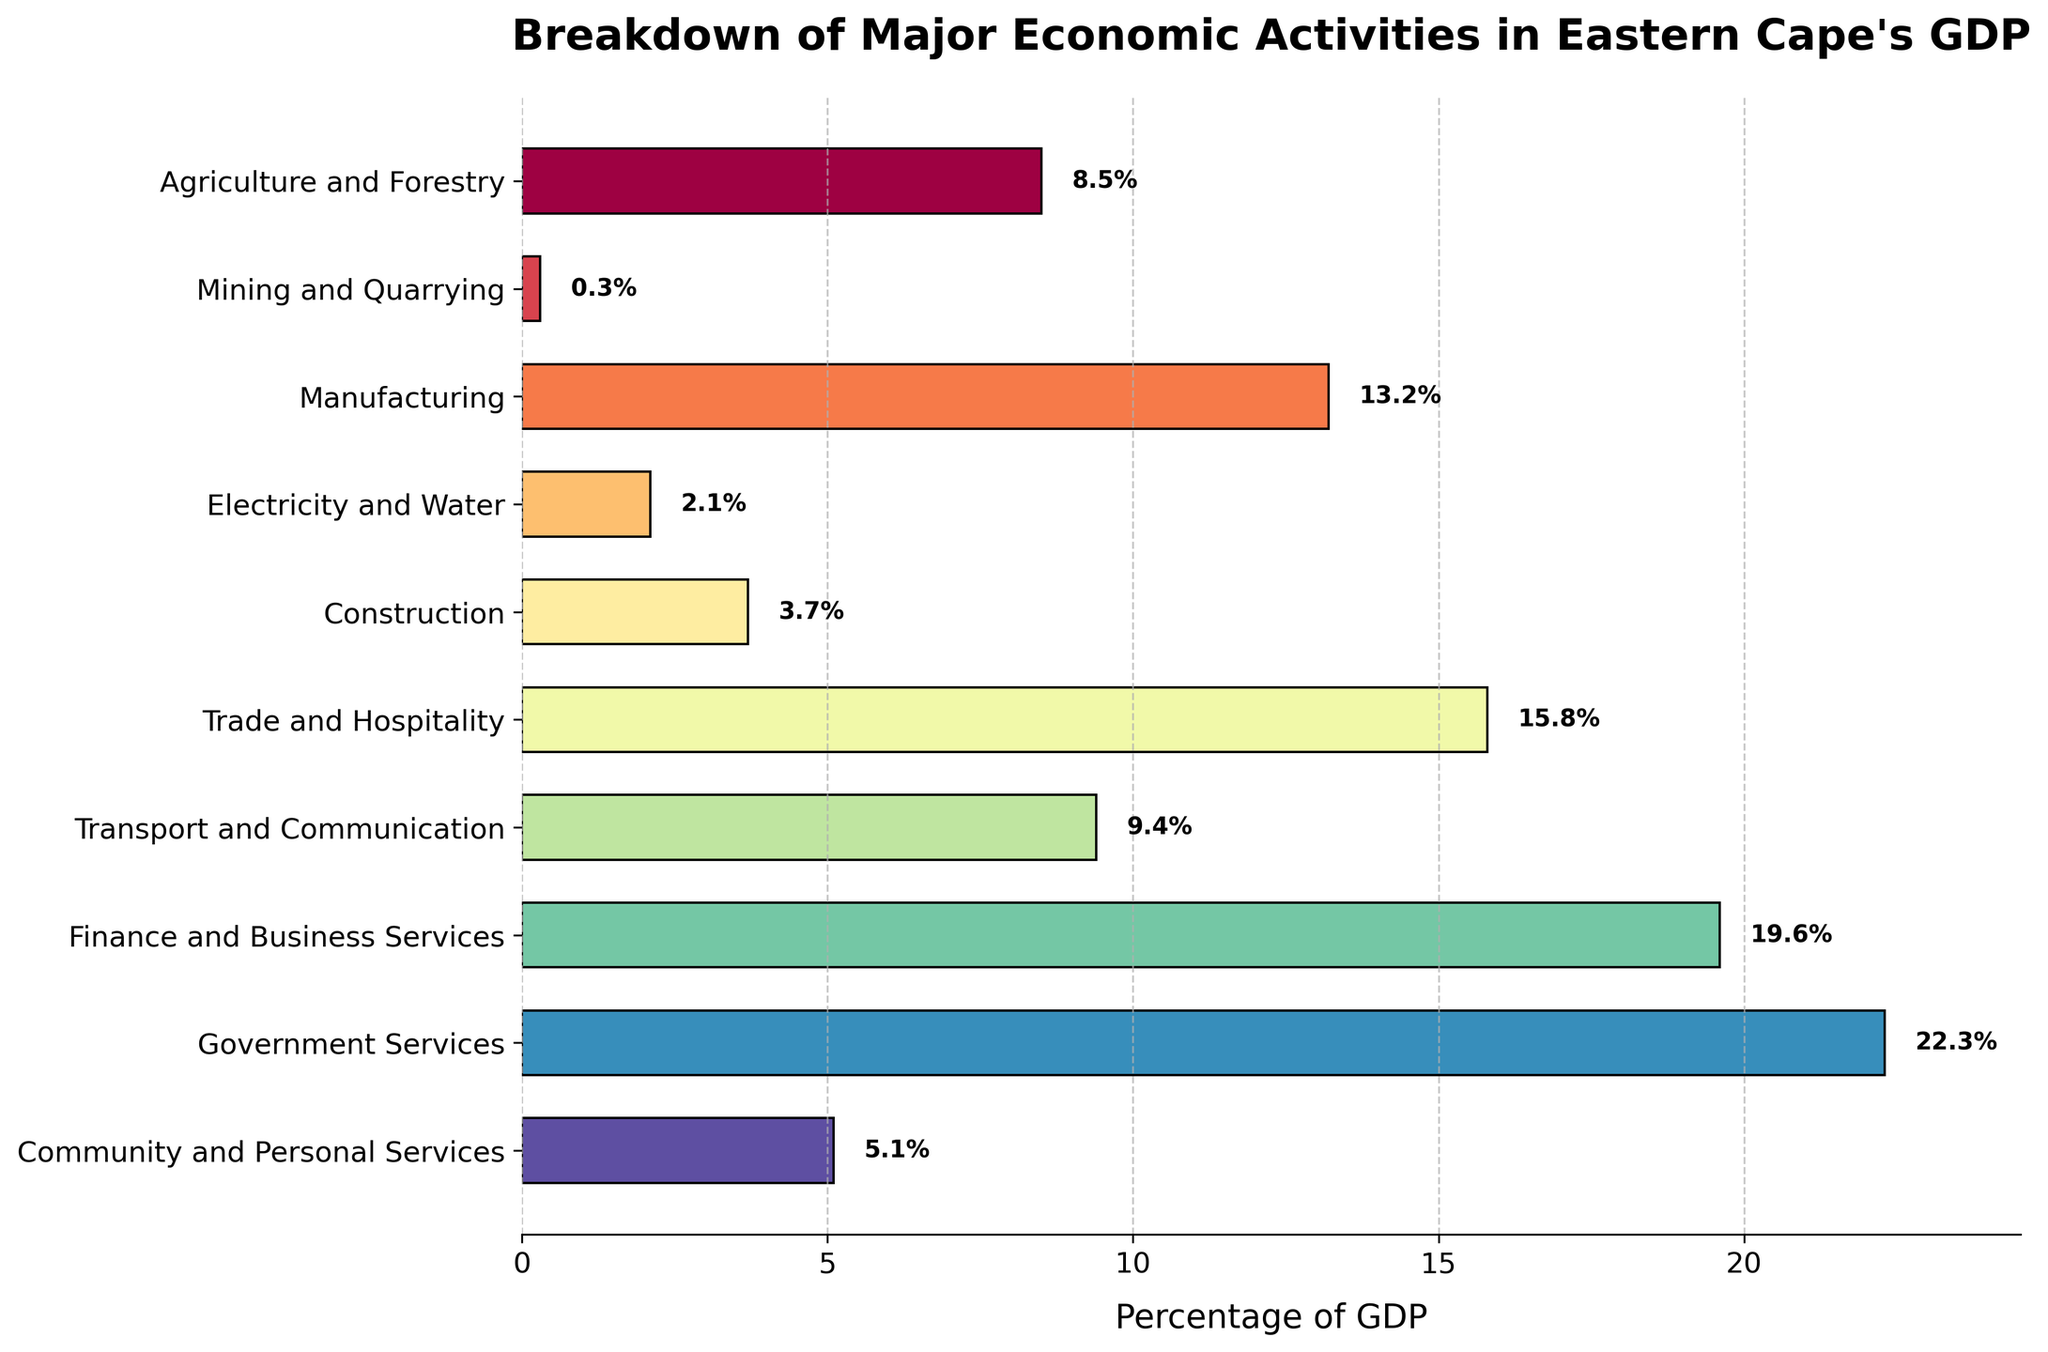what percentage of GDP is contributed by the agriculture and forestry sector? The bar representing the Agriculture and Forestry sector shows a value. This value is labeled directly on the bar.
Answer: 8.5% which sector contributes the least to Eastern Cape's GDP? By checking the length of the bars, the shortest bar represents the Mining and Quarrying sector, which also has the label showing its value.
Answer: Mining and Quarrying how much more does the trade and hospitality sector contribute to GDP compared to the construction sector? The Trade and Hospitality sector contributes 15.8%, and the Construction sector contributes 3.7%. Subtract the second value from the first: 15.8% - 3.7%.
Answer: 12.1% which sector has the highest contribution to GDP? The longest bar represents the Government Services sector, indicating it contributes the most.
Answer: Government Services what is the combined contribution of the finance and business services and government services sectors to the GDP? Add the percentages of Finance and Business Services (19.6%) and Government Services (22.3%): 19.6% + 22.3%.
Answer: 41.9% which sectors have a contribution percentage greater than 10%? Identify all sectors with bars that extend beyond the 10% mark: Manufacturing (13.2%), Trade and Hospitality (15.8%), Finance and Business Services (19.6%), Government Services (22.3%).
Answer: Manufacturing, Trade and Hospitality, Finance and Business Services, Government Services how does the contribution of the transport and communication sector compare to that of the agriculture and forestry sector? The Transport and Communication sector contributes 9.4%, while the Agriculture and Forestry sector contributes 8.5%. 9.4% is slightly greater than 8.5%.
Answer: Transport and Communication is greater how does the longest bar compare in length to the second longest bar? The longest bar is for Government Services at 22.3%, and the second longest is Finance and Business Services at 19.6%. Subtract 19.6% from 22.3%: 22.3% - 19.6%.
Answer: 2.7% which sector has a bar colored on the spectrum between yellow and orange? Identify which bar has a color between yellow and orange in the color scheme used. This corresponds to the sector listed at that color level. In this case, the bar for Government Services appears in this range.
Answer: Government Services 